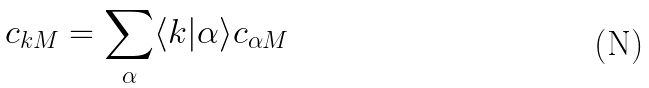<formula> <loc_0><loc_0><loc_500><loc_500>c _ { k M } = \sum _ { \alpha } \langle k | \alpha \rangle c _ { \alpha M }</formula> 